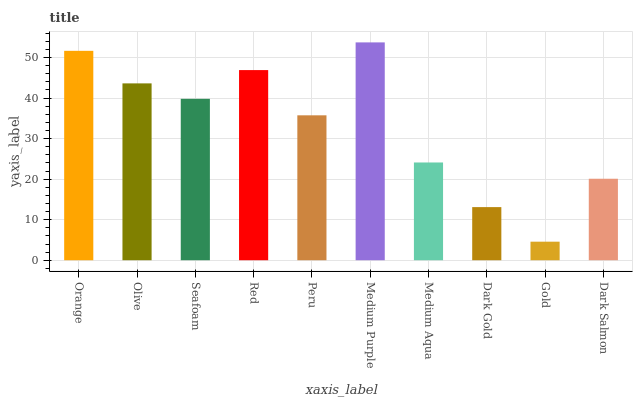Is Gold the minimum?
Answer yes or no. Yes. Is Medium Purple the maximum?
Answer yes or no. Yes. Is Olive the minimum?
Answer yes or no. No. Is Olive the maximum?
Answer yes or no. No. Is Orange greater than Olive?
Answer yes or no. Yes. Is Olive less than Orange?
Answer yes or no. Yes. Is Olive greater than Orange?
Answer yes or no. No. Is Orange less than Olive?
Answer yes or no. No. Is Seafoam the high median?
Answer yes or no. Yes. Is Peru the low median?
Answer yes or no. Yes. Is Orange the high median?
Answer yes or no. No. Is Dark Gold the low median?
Answer yes or no. No. 